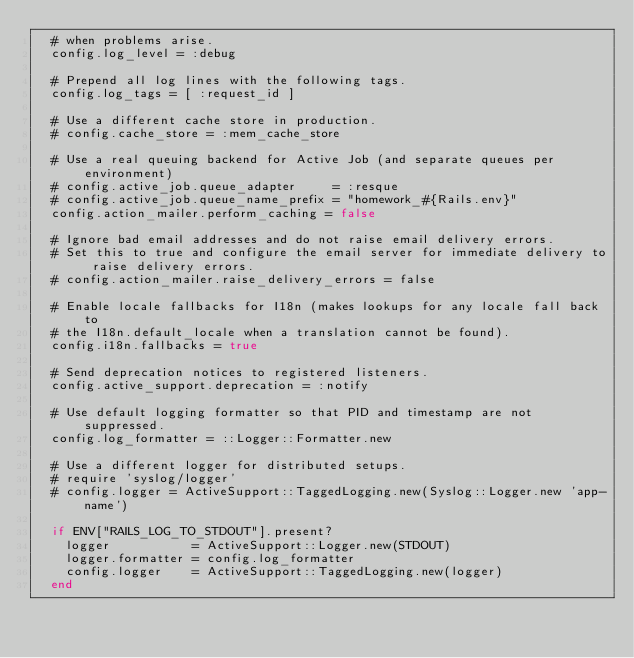Convert code to text. <code><loc_0><loc_0><loc_500><loc_500><_Ruby_>  # when problems arise.
  config.log_level = :debug

  # Prepend all log lines with the following tags.
  config.log_tags = [ :request_id ]

  # Use a different cache store in production.
  # config.cache_store = :mem_cache_store

  # Use a real queuing backend for Active Job (and separate queues per environment)
  # config.active_job.queue_adapter     = :resque
  # config.active_job.queue_name_prefix = "homework_#{Rails.env}"
  config.action_mailer.perform_caching = false

  # Ignore bad email addresses and do not raise email delivery errors.
  # Set this to true and configure the email server for immediate delivery to raise delivery errors.
  # config.action_mailer.raise_delivery_errors = false

  # Enable locale fallbacks for I18n (makes lookups for any locale fall back to
  # the I18n.default_locale when a translation cannot be found).
  config.i18n.fallbacks = true

  # Send deprecation notices to registered listeners.
  config.active_support.deprecation = :notify

  # Use default logging formatter so that PID and timestamp are not suppressed.
  config.log_formatter = ::Logger::Formatter.new

  # Use a different logger for distributed setups.
  # require 'syslog/logger'
  # config.logger = ActiveSupport::TaggedLogging.new(Syslog::Logger.new 'app-name')

  if ENV["RAILS_LOG_TO_STDOUT"].present?
    logger           = ActiveSupport::Logger.new(STDOUT)
    logger.formatter = config.log_formatter
    config.logger    = ActiveSupport::TaggedLogging.new(logger)
  end
</code> 